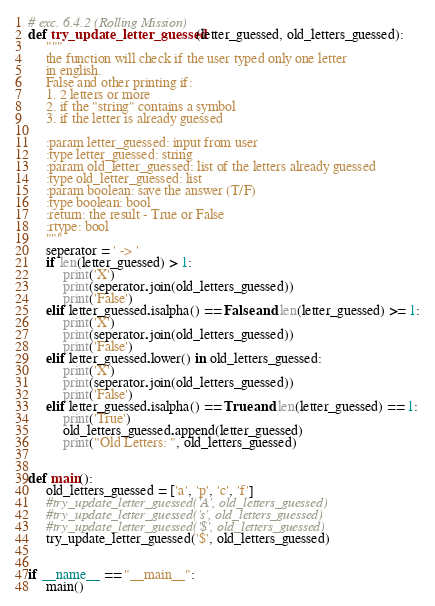Convert code to text. <code><loc_0><loc_0><loc_500><loc_500><_Python_># exc. 6.4.2 (Rolling Mission)
def try_update_letter_guessed(letter_guessed, old_letters_guessed):
     """
     the function will check if the user typed only one letter
     in english.
     False and other printing if:
     1. 2 letters or more
     2. if the "string" contains a symbol
     3. if the letter is already guessed

     :param letter_guessed: input from user
     :type letter_guessed: string
     :param old_letter_guessed: list of the letters already guessed
     :type old_letter_guessed: list
     :param boolean: save the answer (T/F)
     :type boolean: bool
     :return: the result - True or False
     :rtype: bool    
     """
     seperator = ' -> '
     if len(letter_guessed) > 1:
          print('X')
          print(seperator.join(old_letters_guessed))
          print('False')
     elif letter_guessed.isalpha() == False and len(letter_guessed) >= 1:
          print('X')
          print(seperator.join(old_letters_guessed))
          print('False')
     elif letter_guessed.lower() in old_letters_guessed:
          print('X')
          print(seperator.join(old_letters_guessed))
          print('False')
     elif letter_guessed.isalpha() == True and len(letter_guessed) == 1:
          print('True')
          old_letters_guessed.append(letter_guessed)
          print("Old Letters: ", old_letters_guessed)


def main():
     old_letters_guessed = ['a', 'p', 'c', 'f']
     #try_update_letter_guessed('A', old_letters_guessed)
     #try_update_letter_guessed('s', old_letters_guessed)
     #try_update_letter_guessed('$', old_letters_guessed)
     try_update_letter_guessed('$', old_letters_guessed)


if __name__ == "__main__":
     main()</code> 